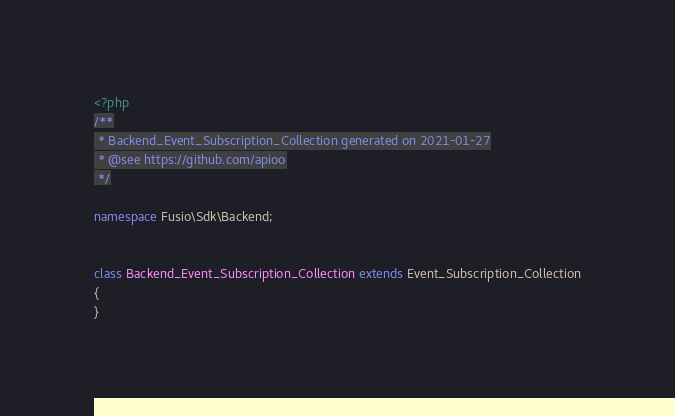<code> <loc_0><loc_0><loc_500><loc_500><_PHP_><?php 
/**
 * Backend_Event_Subscription_Collection generated on 2021-01-27
 * @see https://github.com/apioo
 */

namespace Fusio\Sdk\Backend;


class Backend_Event_Subscription_Collection extends Event_Subscription_Collection
{
}</code> 